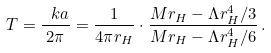<formula> <loc_0><loc_0><loc_500><loc_500>T = \frac { \ k a } { 2 \pi } = \frac { 1 } { 4 \pi r _ { H } } \cdot \frac { M r _ { H } - \Lambda r _ { H } ^ { 4 } / 3 } { M r _ { H } - \Lambda r _ { H } ^ { 4 } / 6 } \, .</formula> 